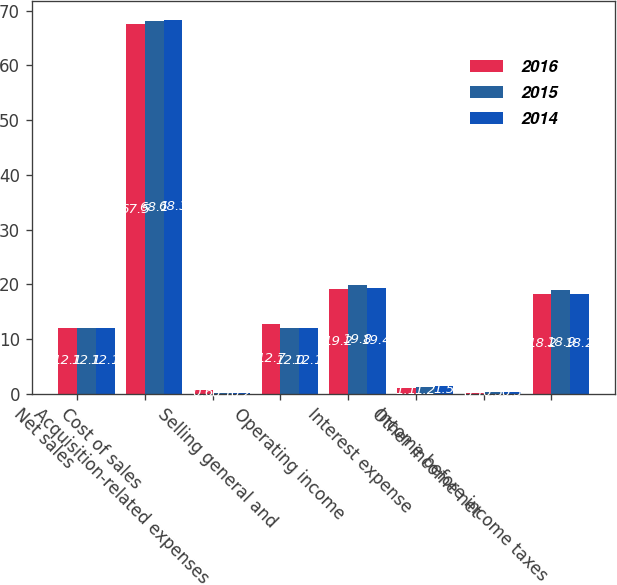<chart> <loc_0><loc_0><loc_500><loc_500><stacked_bar_chart><ecel><fcel>Net sales<fcel>Cost of sales<fcel>Acquisition-related expenses<fcel>Selling general and<fcel>Operating income<fcel>Interest expense<fcel>Other income net<fcel>Income before income taxes<nl><fcel>2016<fcel>12.1<fcel>67.5<fcel>0.6<fcel>12.7<fcel>19.2<fcel>1.1<fcel>0.1<fcel>18.2<nl><fcel>2015<fcel>12.1<fcel>68.1<fcel>0.1<fcel>12<fcel>19.8<fcel>1.2<fcel>0.3<fcel>18.9<nl><fcel>2014<fcel>12.1<fcel>68.3<fcel>0.2<fcel>12.1<fcel>19.4<fcel>1.5<fcel>0.3<fcel>18.2<nl></chart> 